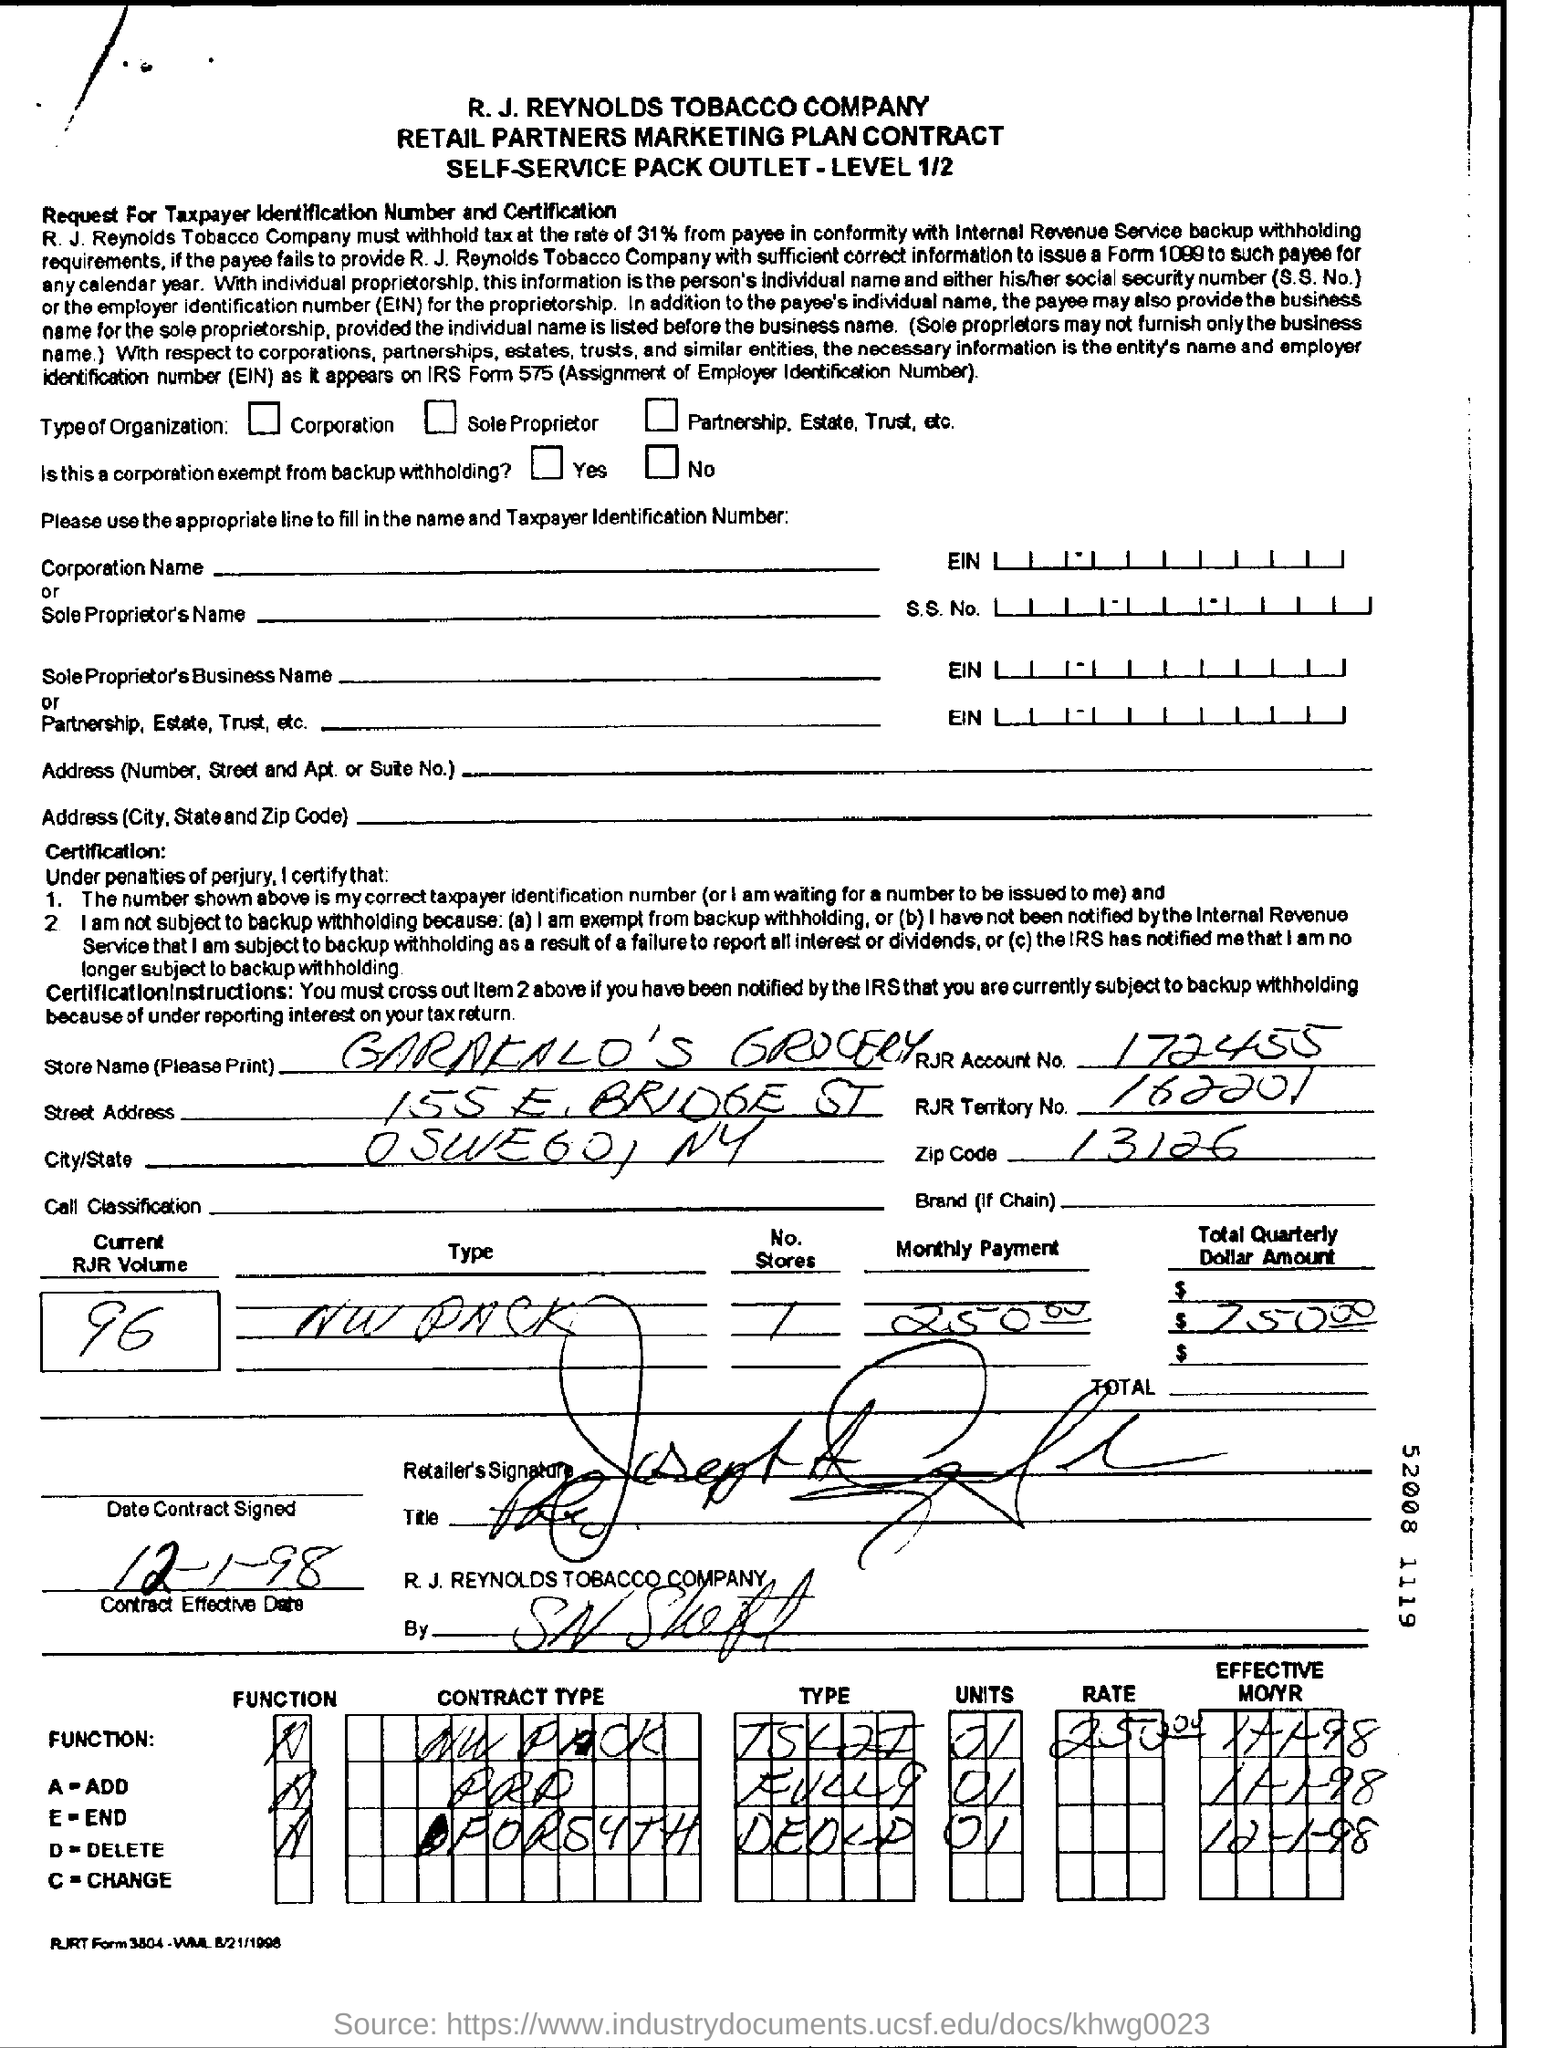Identify some key points in this picture. The monthly payment amount is 250.00. The street name in the address is "Bridge Street. RJR territory number 162201... has been declared. The current volume of RJR is 96 units. With regard to the name of the store, it is called Garakalo's Grocery. 